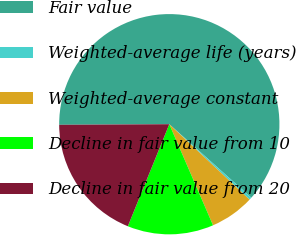Convert chart. <chart><loc_0><loc_0><loc_500><loc_500><pie_chart><fcel>Fair value<fcel>Weighted-average life (years)<fcel>Weighted-average constant<fcel>Decline in fair value from 10<fcel>Decline in fair value from 20<nl><fcel>61.72%<fcel>0.37%<fcel>6.5%<fcel>12.64%<fcel>18.77%<nl></chart> 